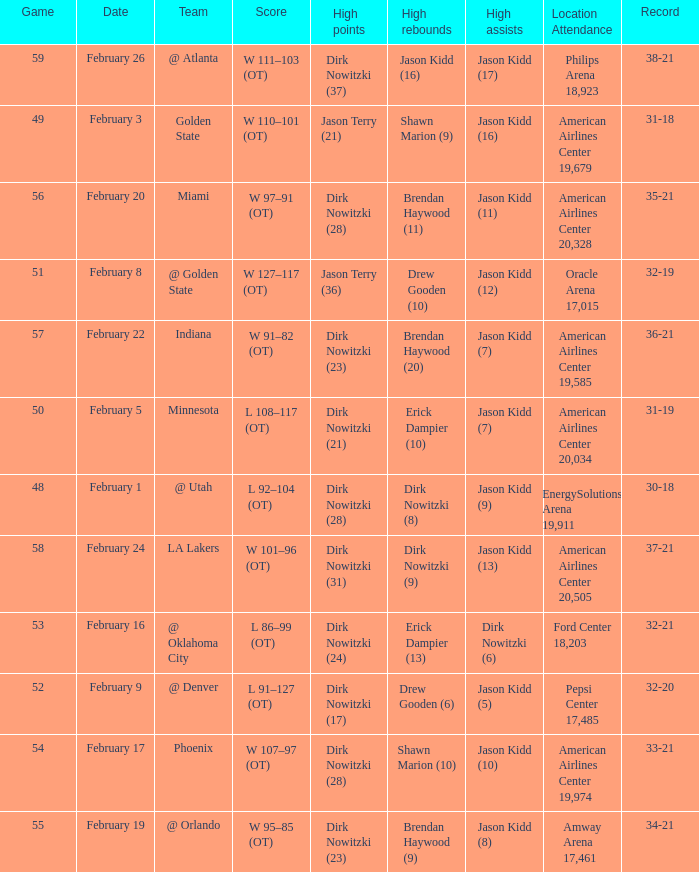Would you be able to parse every entry in this table? {'header': ['Game', 'Date', 'Team', 'Score', 'High points', 'High rebounds', 'High assists', 'Location Attendance', 'Record'], 'rows': [['59', 'February 26', '@ Atlanta', 'W 111–103 (OT)', 'Dirk Nowitzki (37)', 'Jason Kidd (16)', 'Jason Kidd (17)', 'Philips Arena 18,923', '38-21'], ['49', 'February 3', 'Golden State', 'W 110–101 (OT)', 'Jason Terry (21)', 'Shawn Marion (9)', 'Jason Kidd (16)', 'American Airlines Center 19,679', '31-18'], ['56', 'February 20', 'Miami', 'W 97–91 (OT)', 'Dirk Nowitzki (28)', 'Brendan Haywood (11)', 'Jason Kidd (11)', 'American Airlines Center 20,328', '35-21'], ['51', 'February 8', '@ Golden State', 'W 127–117 (OT)', 'Jason Terry (36)', 'Drew Gooden (10)', 'Jason Kidd (12)', 'Oracle Arena 17,015', '32-19'], ['57', 'February 22', 'Indiana', 'W 91–82 (OT)', 'Dirk Nowitzki (23)', 'Brendan Haywood (20)', 'Jason Kidd (7)', 'American Airlines Center 19,585', '36-21'], ['50', 'February 5', 'Minnesota', 'L 108–117 (OT)', 'Dirk Nowitzki (21)', 'Erick Dampier (10)', 'Jason Kidd (7)', 'American Airlines Center 20,034', '31-19'], ['48', 'February 1', '@ Utah', 'L 92–104 (OT)', 'Dirk Nowitzki (28)', 'Dirk Nowitzki (8)', 'Jason Kidd (9)', 'EnergySolutions Arena 19,911', '30-18'], ['58', 'February 24', 'LA Lakers', 'W 101–96 (OT)', 'Dirk Nowitzki (31)', 'Dirk Nowitzki (9)', 'Jason Kidd (13)', 'American Airlines Center 20,505', '37-21'], ['53', 'February 16', '@ Oklahoma City', 'L 86–99 (OT)', 'Dirk Nowitzki (24)', 'Erick Dampier (13)', 'Dirk Nowitzki (6)', 'Ford Center 18,203', '32-21'], ['52', 'February 9', '@ Denver', 'L 91–127 (OT)', 'Dirk Nowitzki (17)', 'Drew Gooden (6)', 'Jason Kidd (5)', 'Pepsi Center 17,485', '32-20'], ['54', 'February 17', 'Phoenix', 'W 107–97 (OT)', 'Dirk Nowitzki (28)', 'Shawn Marion (10)', 'Jason Kidd (10)', 'American Airlines Center 19,974', '33-21'], ['55', 'February 19', '@ Orlando', 'W 95–85 (OT)', 'Dirk Nowitzki (23)', 'Brendan Haywood (9)', 'Jason Kidd (8)', 'Amway Arena 17,461', '34-21']]} Who had the most high assists with a record of 32-19? Jason Kidd (12). 